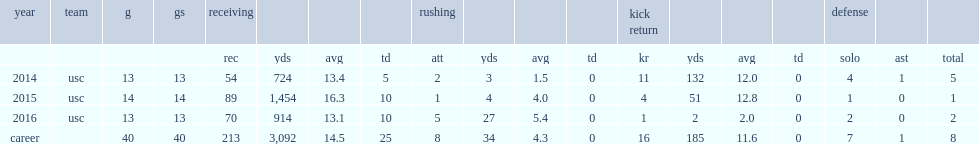In 2016, how many receiving yards did juju smith-schuster played 13 games with? 914.0. In 2016, how many touchdowns did juju smith-schuster played 13 games with? 10.0. 